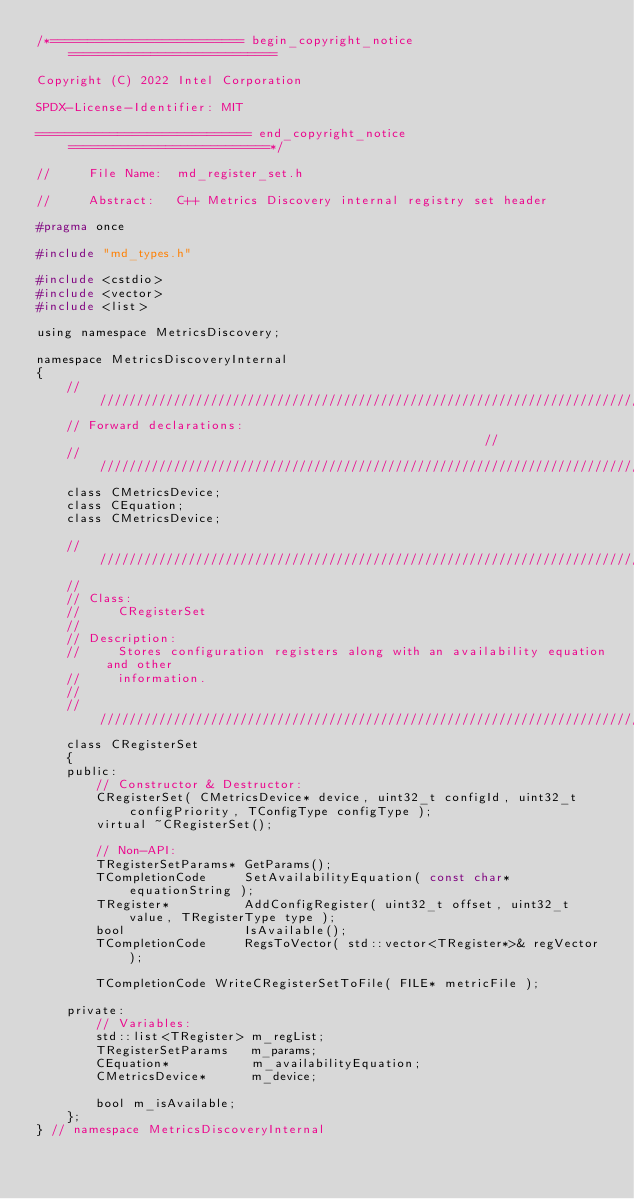<code> <loc_0><loc_0><loc_500><loc_500><_C_>/*========================== begin_copyright_notice ============================

Copyright (C) 2022 Intel Corporation

SPDX-License-Identifier: MIT

============================= end_copyright_notice ===========================*/

//     File Name:  md_register_set.h

//     Abstract:   C++ Metrics Discovery internal registry set header

#pragma once

#include "md_types.h"

#include <cstdio>
#include <vector>
#include <list>

using namespace MetricsDiscovery;

namespace MetricsDiscoveryInternal
{
    ///////////////////////////////////////////////////////////////////////////////
    // Forward declarations:                                                     //
    ///////////////////////////////////////////////////////////////////////////////
    class CMetricsDevice;
    class CEquation;
    class CMetricsDevice;

    //////////////////////////////////////////////////////////////////////////////
    //
    // Class:
    //     CRegisterSet
    //
    // Description:
    //     Stores configuration registers along with an availability equation and other
    //     information.
    //
    //////////////////////////////////////////////////////////////////////////////
    class CRegisterSet
    {
    public:
        // Constructor & Destructor:
        CRegisterSet( CMetricsDevice* device, uint32_t configId, uint32_t configPriority, TConfigType configType );
        virtual ~CRegisterSet();

        // Non-API:
        TRegisterSetParams* GetParams();
        TCompletionCode     SetAvailabilityEquation( const char* equationString );
        TRegister*          AddConfigRegister( uint32_t offset, uint32_t value, TRegisterType type );
        bool                IsAvailable();
        TCompletionCode     RegsToVector( std::vector<TRegister*>& regVector );

        TCompletionCode WriteCRegisterSetToFile( FILE* metricFile );

    private:
        // Variables:
        std::list<TRegister> m_regList;
        TRegisterSetParams   m_params;
        CEquation*           m_availabilityEquation;
        CMetricsDevice*      m_device;

        bool m_isAvailable;
    };
} // namespace MetricsDiscoveryInternal
</code> 